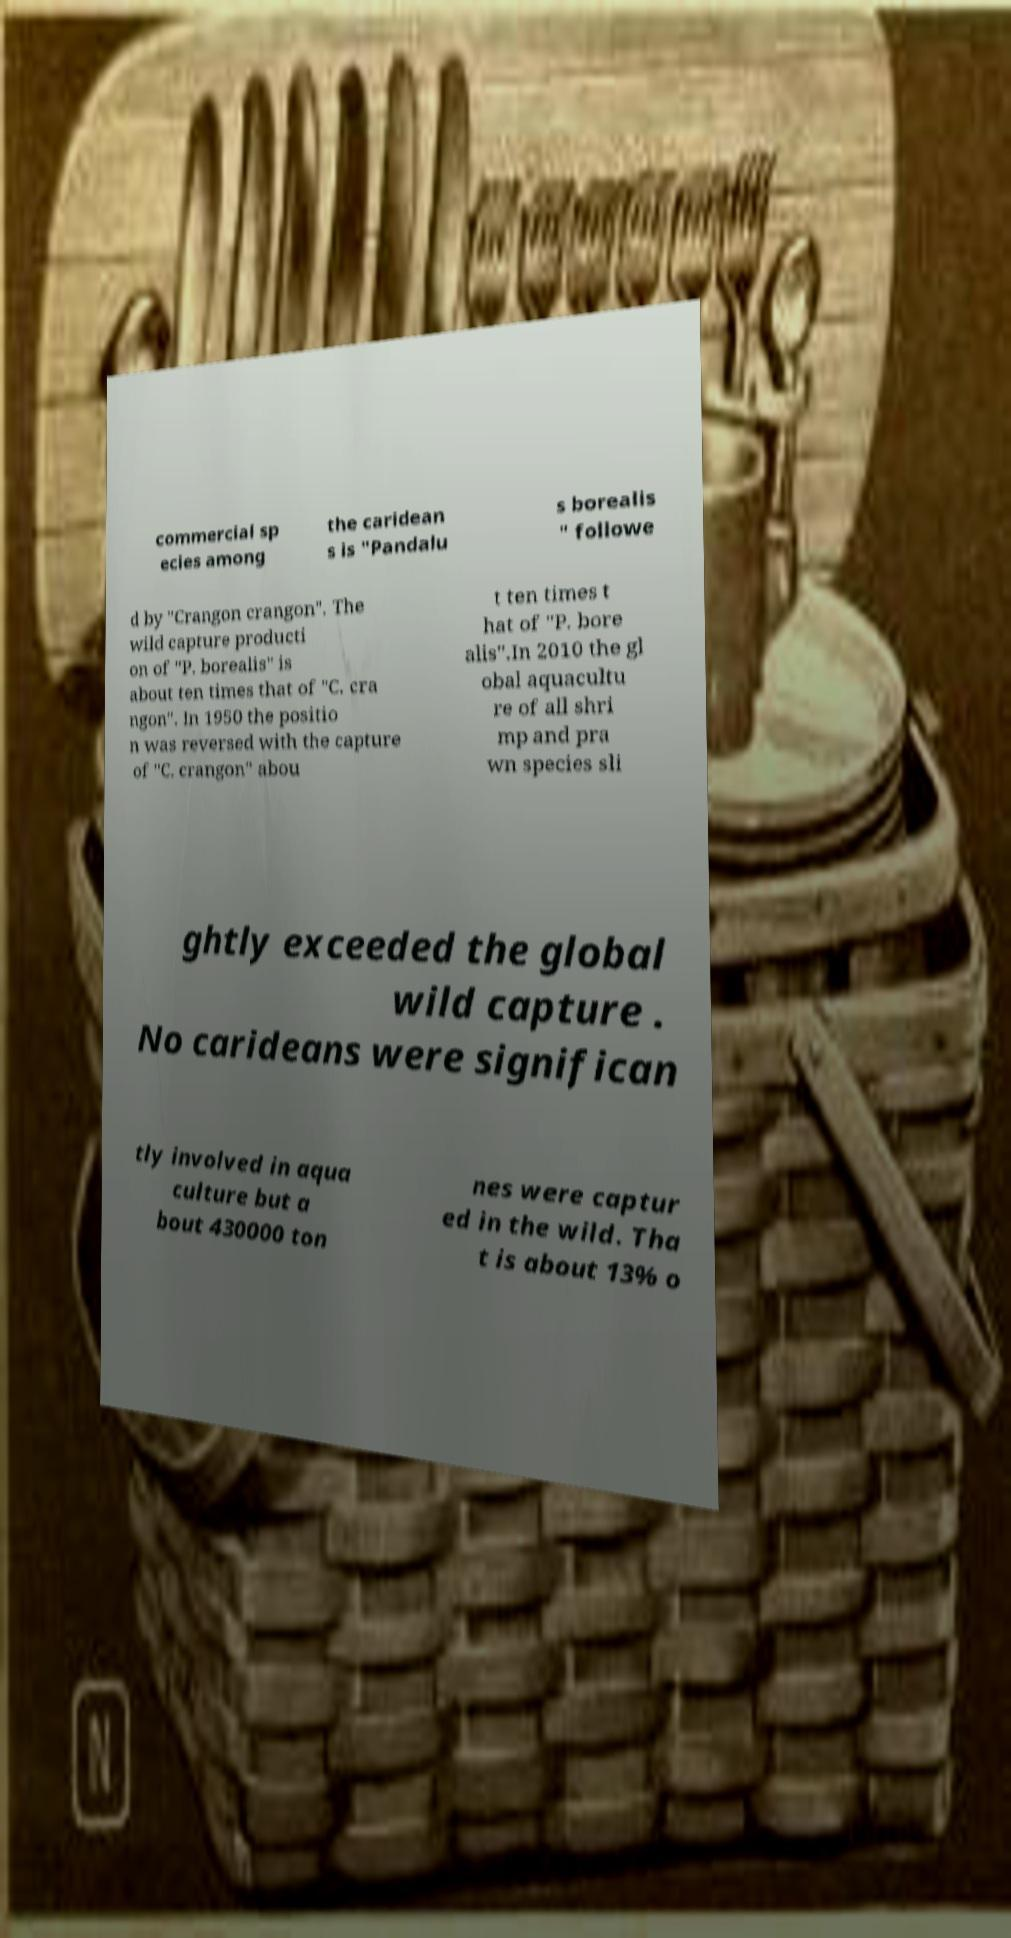There's text embedded in this image that I need extracted. Can you transcribe it verbatim? commercial sp ecies among the caridean s is "Pandalu s borealis " followe d by "Crangon crangon". The wild capture producti on of "P. borealis" is about ten times that of "C. cra ngon". In 1950 the positio n was reversed with the capture of "C. crangon" abou t ten times t hat of "P. bore alis".In 2010 the gl obal aquacultu re of all shri mp and pra wn species sli ghtly exceeded the global wild capture . No carideans were significan tly involved in aqua culture but a bout 430000 ton nes were captur ed in the wild. Tha t is about 13% o 